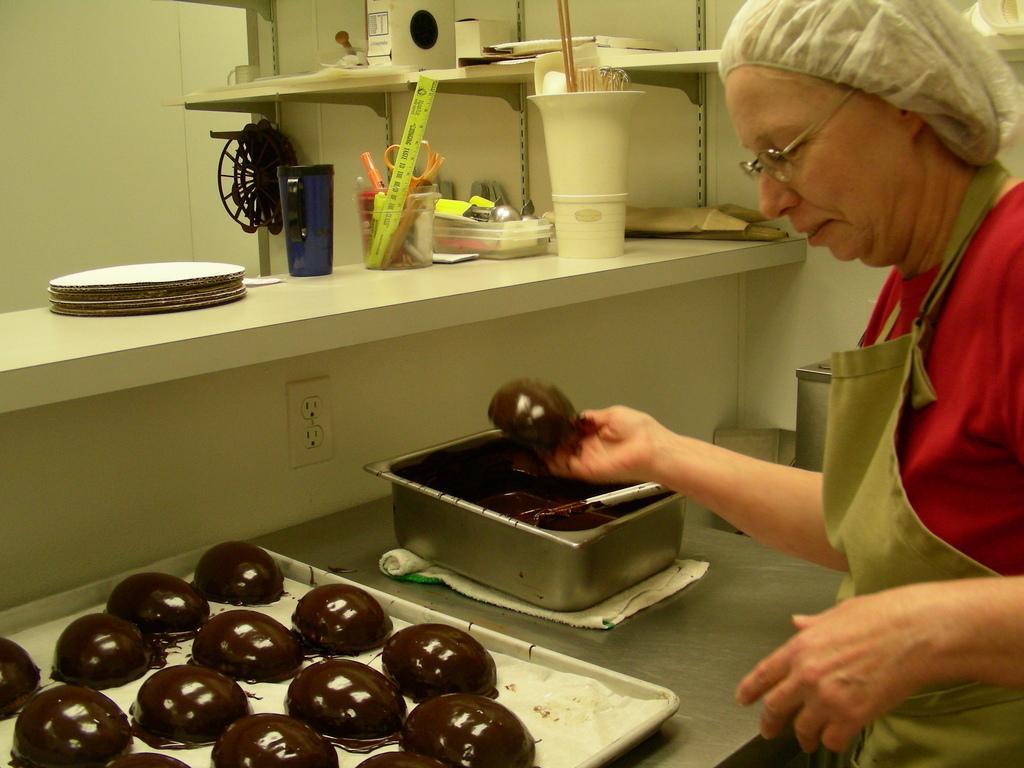Describe this image in one or two sentences. In the background we can see a scale, scissors and few objects in a holder. We can see objects are placed on the racks. In this picture we can see a platform and on the platform we can see the tray and a container. We can see the food in a tray and chocolate syrup, spoon in a container. We can see a cloth under the container. We can see a person wearing a cap, apron, spectacles and holding the food. 